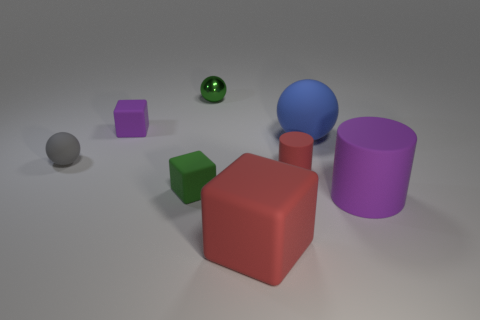What size is the blue sphere that is made of the same material as the purple cylinder?
Offer a very short reply. Large. There is a large object that is in front of the big matte ball and to the left of the purple cylinder; what material is it made of?
Keep it short and to the point. Rubber. How many brown rubber objects are the same size as the blue matte object?
Offer a very short reply. 0. There is a big object that is the same shape as the tiny green metallic thing; what material is it?
Provide a succinct answer. Rubber. How many objects are small green objects in front of the small green metallic sphere or small red rubber cylinders that are to the left of the large purple object?
Keep it short and to the point. 2. There is a tiny green metal thing; does it have the same shape as the purple object behind the tiny gray thing?
Provide a succinct answer. No. The small green object in front of the red object on the right side of the matte block on the right side of the tiny green metal ball is what shape?
Your response must be concise. Cube. How many other objects are the same material as the blue thing?
Offer a terse response. 6. How many things are small rubber objects that are to the right of the tiny purple thing or tiny blue matte things?
Give a very brief answer. 2. What is the shape of the purple matte object that is behind the small ball that is in front of the big blue object?
Offer a very short reply. Cube. 